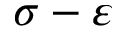Convert formula to latex. <formula><loc_0><loc_0><loc_500><loc_500>\sigma - \varepsilon</formula> 